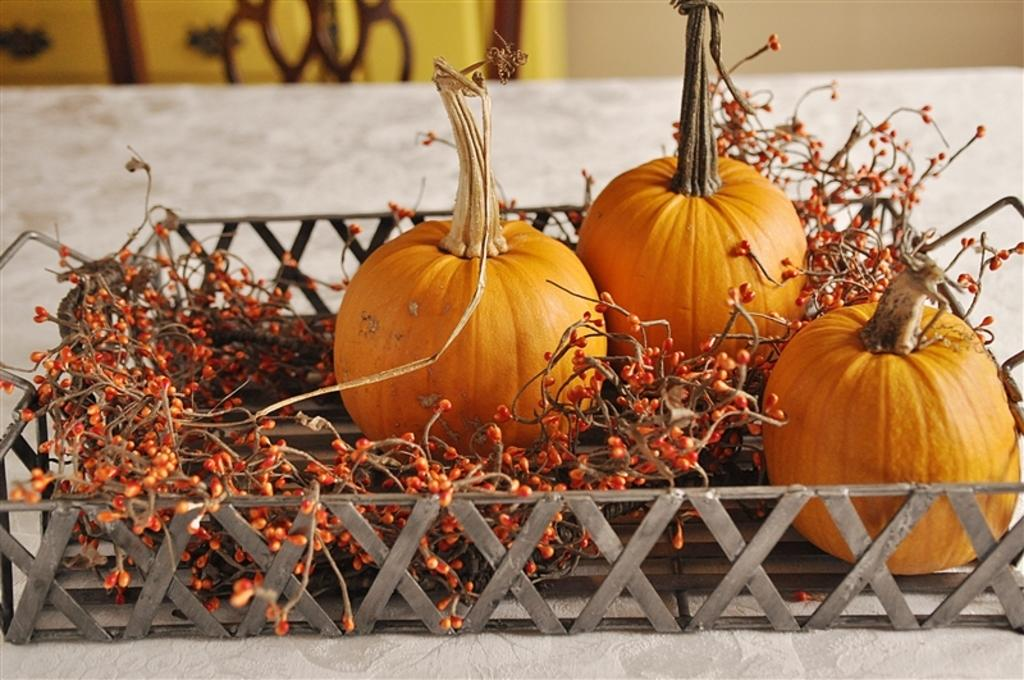What type of fruits or vegetables are in the image? There are pumpkins and berries in the image. How are the pumpkins and berries arranged in the image? The pumpkins and berries are placed in a tray. Where is the tray located in the image? The tray is placed on a table. What is covering the table in the image? The table has a cloth covering it. Can you describe the top part of the image? The top part of the image is blurred. What type of pencil can be seen in the image? There is no pencil present in the image. How does the crib fit into the image? There is no crib present in the image. 